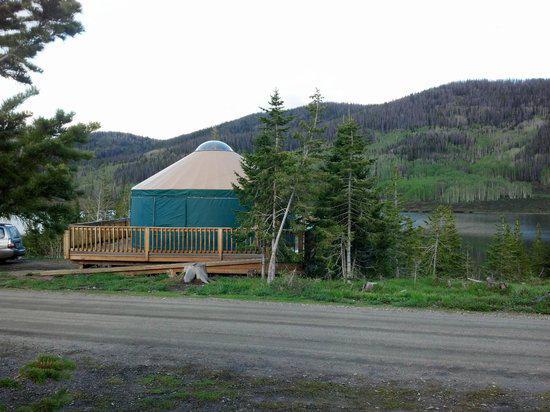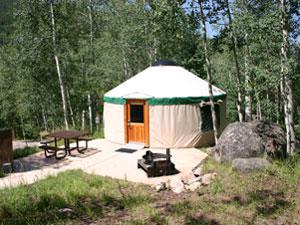The first image is the image on the left, the second image is the image on the right. Considering the images on both sides, is "All of the images display the interior of the hut." valid? Answer yes or no. No. The first image is the image on the left, the second image is the image on the right. Considering the images on both sides, is "The interior of a round house shows its fan-shaped ceiling and lattice walls." valid? Answer yes or no. No. 